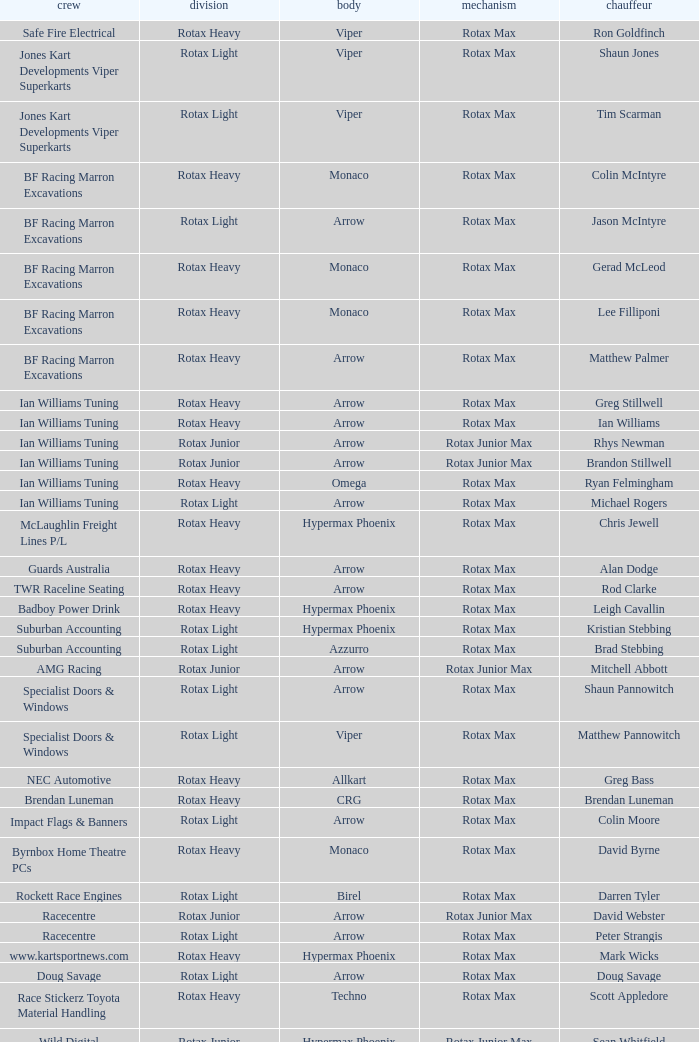What is the name of the team whose class is Rotax Light? Jones Kart Developments Viper Superkarts, Jones Kart Developments Viper Superkarts, BF Racing Marron Excavations, Ian Williams Tuning, Suburban Accounting, Suburban Accounting, Specialist Doors & Windows, Specialist Doors & Windows, Impact Flags & Banners, Rockett Race Engines, Racecentre, Doug Savage. Could you help me parse every detail presented in this table? {'header': ['crew', 'division', 'body', 'mechanism', 'chauffeur'], 'rows': [['Safe Fire Electrical', 'Rotax Heavy', 'Viper', 'Rotax Max', 'Ron Goldfinch'], ['Jones Kart Developments Viper Superkarts', 'Rotax Light', 'Viper', 'Rotax Max', 'Shaun Jones'], ['Jones Kart Developments Viper Superkarts', 'Rotax Light', 'Viper', 'Rotax Max', 'Tim Scarman'], ['BF Racing Marron Excavations', 'Rotax Heavy', 'Monaco', 'Rotax Max', 'Colin McIntyre'], ['BF Racing Marron Excavations', 'Rotax Light', 'Arrow', 'Rotax Max', 'Jason McIntyre'], ['BF Racing Marron Excavations', 'Rotax Heavy', 'Monaco', 'Rotax Max', 'Gerad McLeod'], ['BF Racing Marron Excavations', 'Rotax Heavy', 'Monaco', 'Rotax Max', 'Lee Filliponi'], ['BF Racing Marron Excavations', 'Rotax Heavy', 'Arrow', 'Rotax Max', 'Matthew Palmer'], ['Ian Williams Tuning', 'Rotax Heavy', 'Arrow', 'Rotax Max', 'Greg Stillwell'], ['Ian Williams Tuning', 'Rotax Heavy', 'Arrow', 'Rotax Max', 'Ian Williams'], ['Ian Williams Tuning', 'Rotax Junior', 'Arrow', 'Rotax Junior Max', 'Rhys Newman'], ['Ian Williams Tuning', 'Rotax Junior', 'Arrow', 'Rotax Junior Max', 'Brandon Stillwell'], ['Ian Williams Tuning', 'Rotax Heavy', 'Omega', 'Rotax Max', 'Ryan Felmingham'], ['Ian Williams Tuning', 'Rotax Light', 'Arrow', 'Rotax Max', 'Michael Rogers'], ['McLaughlin Freight Lines P/L', 'Rotax Heavy', 'Hypermax Phoenix', 'Rotax Max', 'Chris Jewell'], ['Guards Australia', 'Rotax Heavy', 'Arrow', 'Rotax Max', 'Alan Dodge'], ['TWR Raceline Seating', 'Rotax Heavy', 'Arrow', 'Rotax Max', 'Rod Clarke'], ['Badboy Power Drink', 'Rotax Heavy', 'Hypermax Phoenix', 'Rotax Max', 'Leigh Cavallin'], ['Suburban Accounting', 'Rotax Light', 'Hypermax Phoenix', 'Rotax Max', 'Kristian Stebbing'], ['Suburban Accounting', 'Rotax Light', 'Azzurro', 'Rotax Max', 'Brad Stebbing'], ['AMG Racing', 'Rotax Junior', 'Arrow', 'Rotax Junior Max', 'Mitchell Abbott'], ['Specialist Doors & Windows', 'Rotax Light', 'Arrow', 'Rotax Max', 'Shaun Pannowitch'], ['Specialist Doors & Windows', 'Rotax Light', 'Viper', 'Rotax Max', 'Matthew Pannowitch'], ['NEC Automotive', 'Rotax Heavy', 'Allkart', 'Rotax Max', 'Greg Bass'], ['Brendan Luneman', 'Rotax Heavy', 'CRG', 'Rotax Max', 'Brendan Luneman'], ['Impact Flags & Banners', 'Rotax Light', 'Arrow', 'Rotax Max', 'Colin Moore'], ['Byrnbox Home Theatre PCs', 'Rotax Heavy', 'Monaco', 'Rotax Max', 'David Byrne'], ['Rockett Race Engines', 'Rotax Light', 'Birel', 'Rotax Max', 'Darren Tyler'], ['Racecentre', 'Rotax Junior', 'Arrow', 'Rotax Junior Max', 'David Webster'], ['Racecentre', 'Rotax Light', 'Arrow', 'Rotax Max', 'Peter Strangis'], ['www.kartsportnews.com', 'Rotax Heavy', 'Hypermax Phoenix', 'Rotax Max', 'Mark Wicks'], ['Doug Savage', 'Rotax Light', 'Arrow', 'Rotax Max', 'Doug Savage'], ['Race Stickerz Toyota Material Handling', 'Rotax Heavy', 'Techno', 'Rotax Max', 'Scott Appledore'], ['Wild Digital', 'Rotax Junior', 'Hypermax Phoenix', 'Rotax Junior Max', 'Sean Whitfield'], ['John Bartlett', 'Rotax Heavy', 'Hypermax Phoenix', 'Rotax Max', 'John Bartlett']]} 